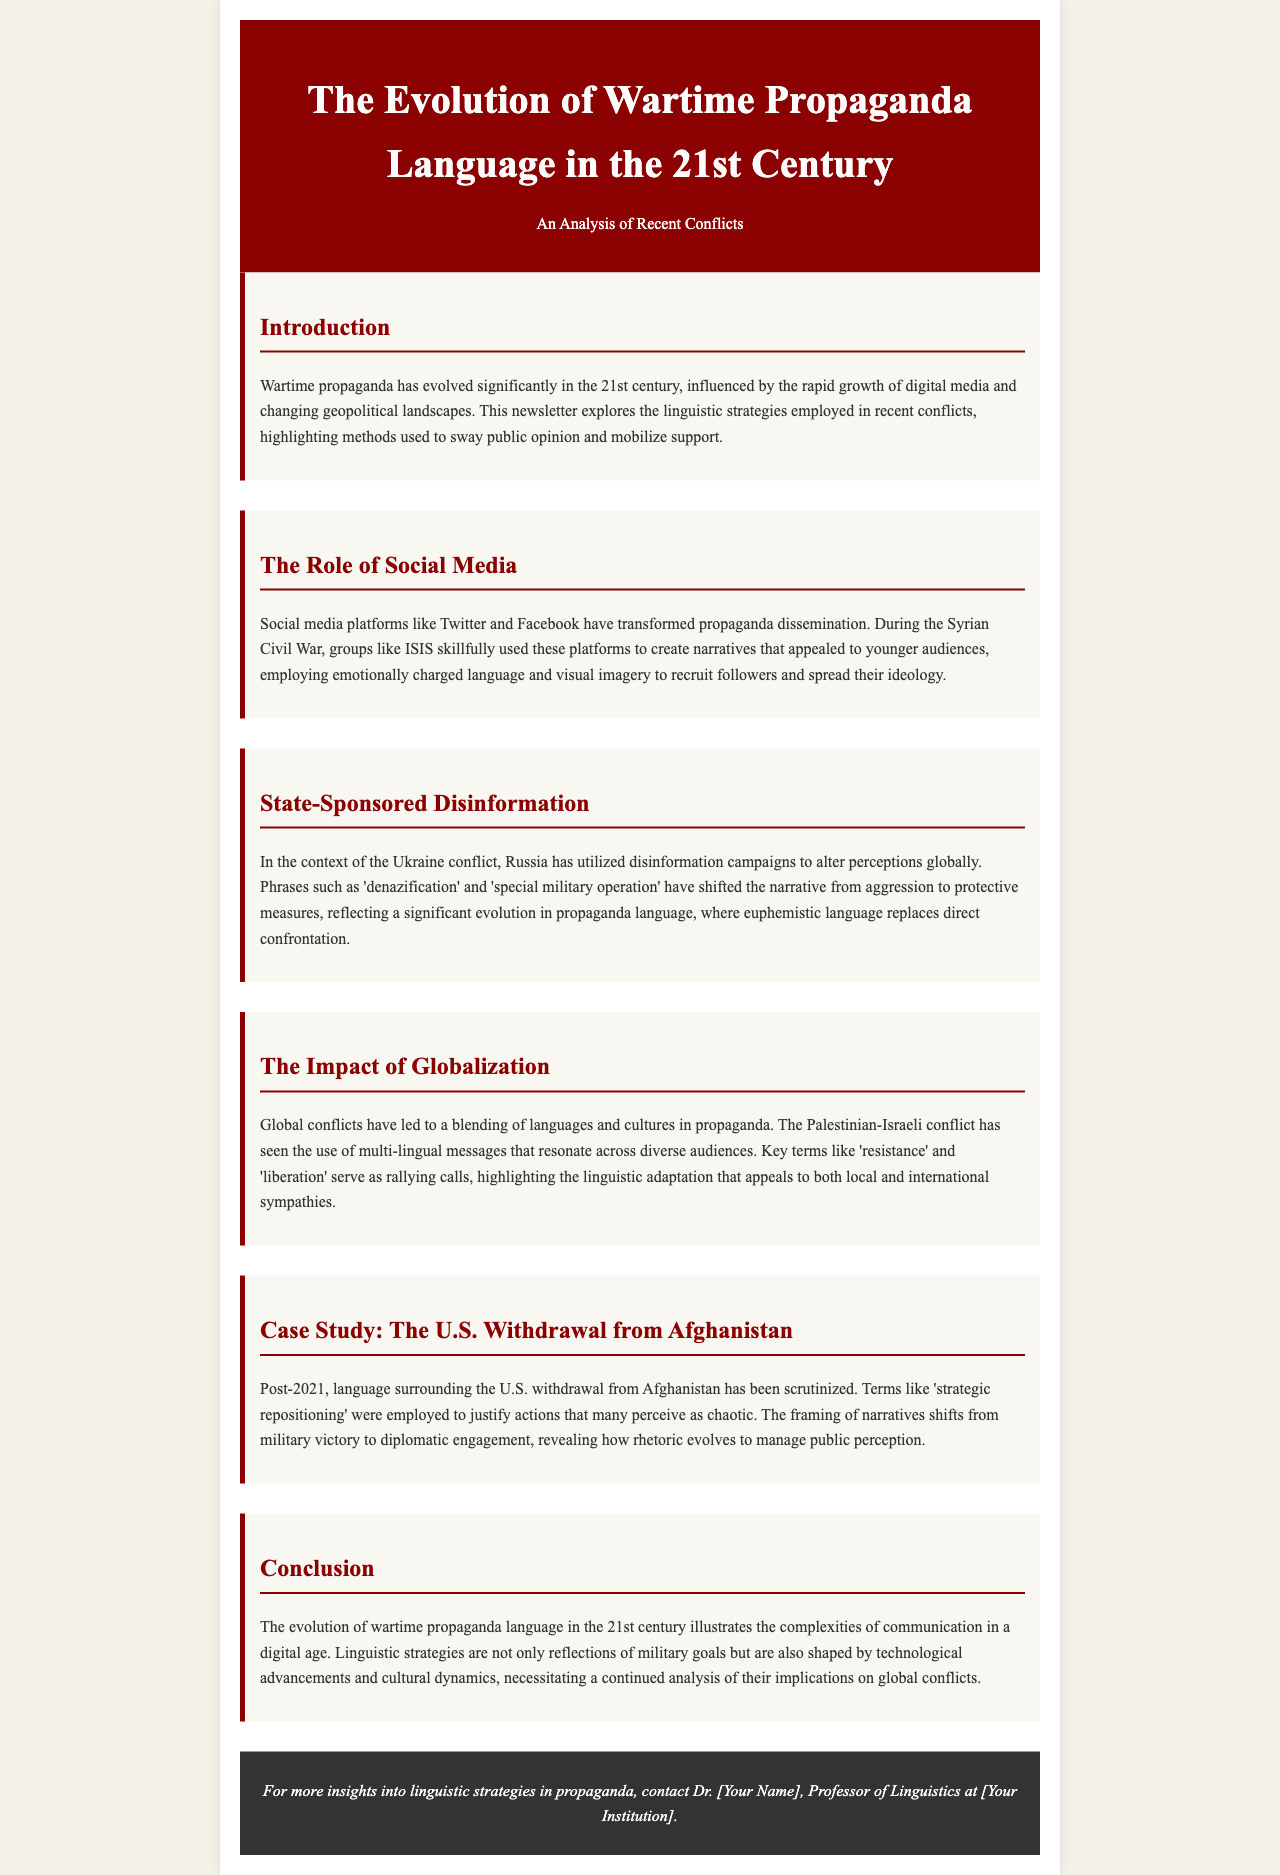What is the title of the newsletter? The title appears at the top of the document and states the main subject discussed, which is "The Evolution of Wartime Propaganda Language in the 21st Century."
Answer: The Evolution of Wartime Propaganda Language in the 21st Century Which recent conflict is mentioned as using social media for propaganda? The document references the Syrian Civil War specifically in the context of social media propaganda efforts.
Answer: Syrian Civil War What euphemistic phrase has been used in the Ukraine conflict? The newsletter highlights certain phrases that are part of the propaganda language, particularly "denazification."
Answer: denazification What terms are used in the Palestinian-Israeli conflict to resonate with diverse audiences? The document mentions key terms that have been used in this context, such as "resistance" and "liberation."
Answer: resistance and liberation In what year did the U.S. withdrawal from Afghanistan occur? The document references the post-2021 scrutiny of language surrounding the withdrawal from Afghanistan.
Answer: 2021 What is a key linguistic strategy highlighted in the document regarding 21st-century wartime propaganda? The document discusses how linguistic strategies reflect military goals and are also shaped by external factors like technological advancements and culture.
Answer: Framing narratives How does globalization affect wartime propaganda language? The newsletter indicates that globalization leads to a blending of languages and cultures in propaganda efforts.
Answer: Blending of languages and cultures Who is the contact person for more insights into the topic? At the end of the document, a placeholder is provided for contact information, suggesting the person's name is to be filled in.
Answer: Dr. [Your Name] 